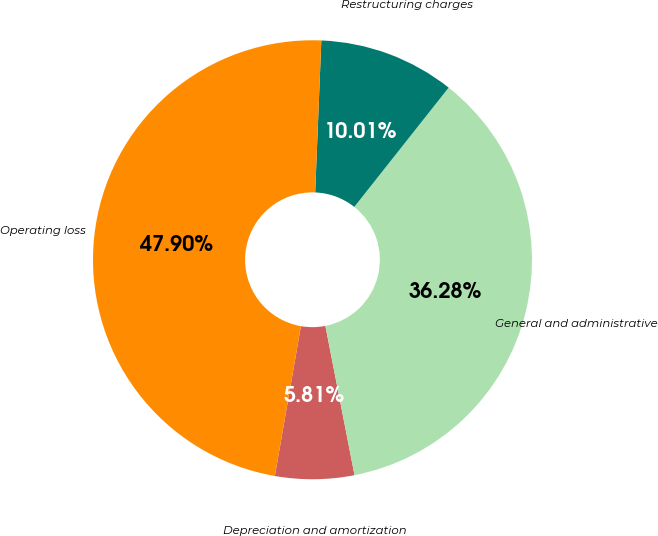<chart> <loc_0><loc_0><loc_500><loc_500><pie_chart><fcel>Depreciation and amortization<fcel>General and administrative<fcel>Restructuring charges<fcel>Operating loss<nl><fcel>5.81%<fcel>36.28%<fcel>10.01%<fcel>47.9%<nl></chart> 